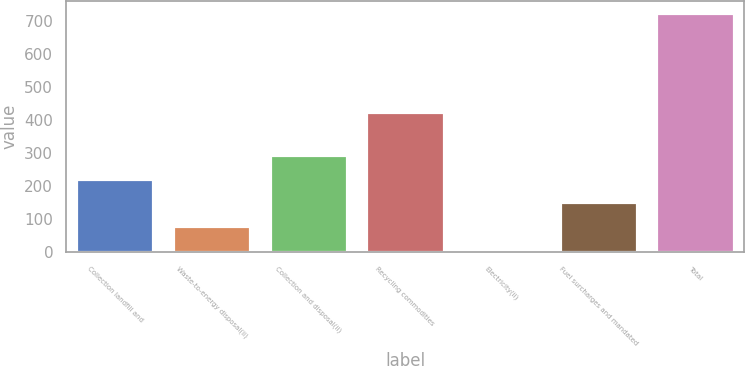Convert chart. <chart><loc_0><loc_0><loc_500><loc_500><bar_chart><fcel>Collection landfill and<fcel>Waste-to-energy disposal(ii)<fcel>Collection and disposal(ii)<fcel>Recycling commodities<fcel>Electricity(ii)<fcel>Fuel surcharges and mandated<fcel>Total<nl><fcel>222.1<fcel>78.7<fcel>293.8<fcel>423<fcel>7<fcel>150.4<fcel>724<nl></chart> 